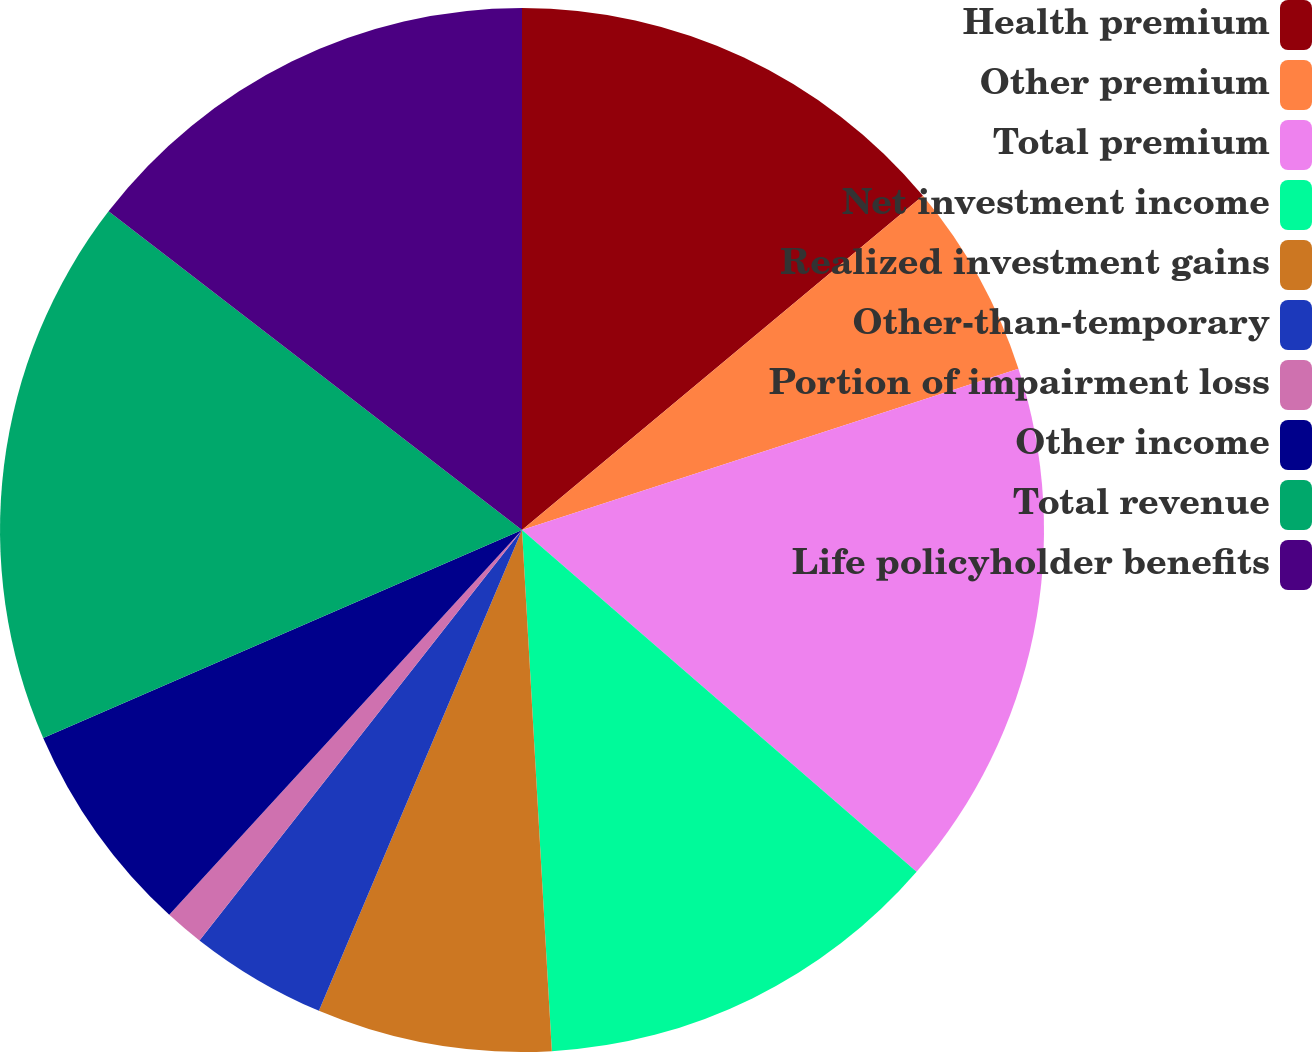Convert chart to OTSL. <chart><loc_0><loc_0><loc_500><loc_500><pie_chart><fcel>Health premium<fcel>Other premium<fcel>Total premium<fcel>Net investment income<fcel>Realized investment gains<fcel>Other-than-temporary<fcel>Portion of impairment loss<fcel>Other income<fcel>Total revenue<fcel>Life policyholder benefits<nl><fcel>13.94%<fcel>6.06%<fcel>16.36%<fcel>12.73%<fcel>7.27%<fcel>4.24%<fcel>1.21%<fcel>6.67%<fcel>16.97%<fcel>14.55%<nl></chart> 